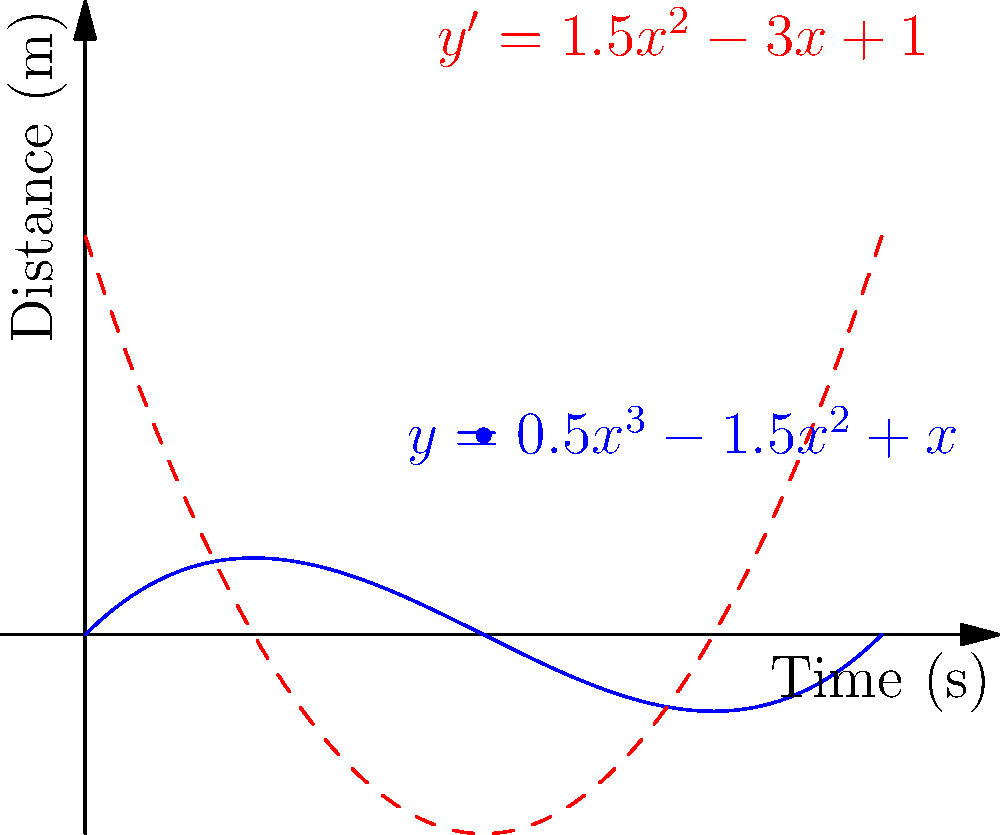In a robot fighting competition, you're optimizing the trajectory of your robot's punch using the cubic polynomial function $y = 0.5x^3 - 1.5x^2 + x$, where $y$ is the distance traveled (in meters) and $x$ is the time (in seconds). At what time does the robot's fist reach its maximum velocity during the 2-second punch motion? To find the time of maximum velocity, we need to follow these steps:

1) The velocity is given by the first derivative of the position function:
   $v(x) = y'(x) = 1.5x^2 - 3x + 1$

2) The maximum velocity occurs when the acceleration (second derivative) is zero:
   $a(x) = v'(x) = y''(x) = 3x - 3$

3) Set the acceleration to zero and solve for x:
   $3x - 3 = 0$
   $3x = 3$
   $x = 1$

4) To confirm this is a maximum (not minimum) velocity, we can check that the third derivative is negative at x = 1:
   $y'''(x) = 3$, which is always positive, confirming x = 1 gives a maximum velocity.

5) We should also verify that this occurs within the given 2-second time frame, which it does.

Therefore, the maximum velocity occurs at 1 second into the punch motion.
Answer: 1 second 